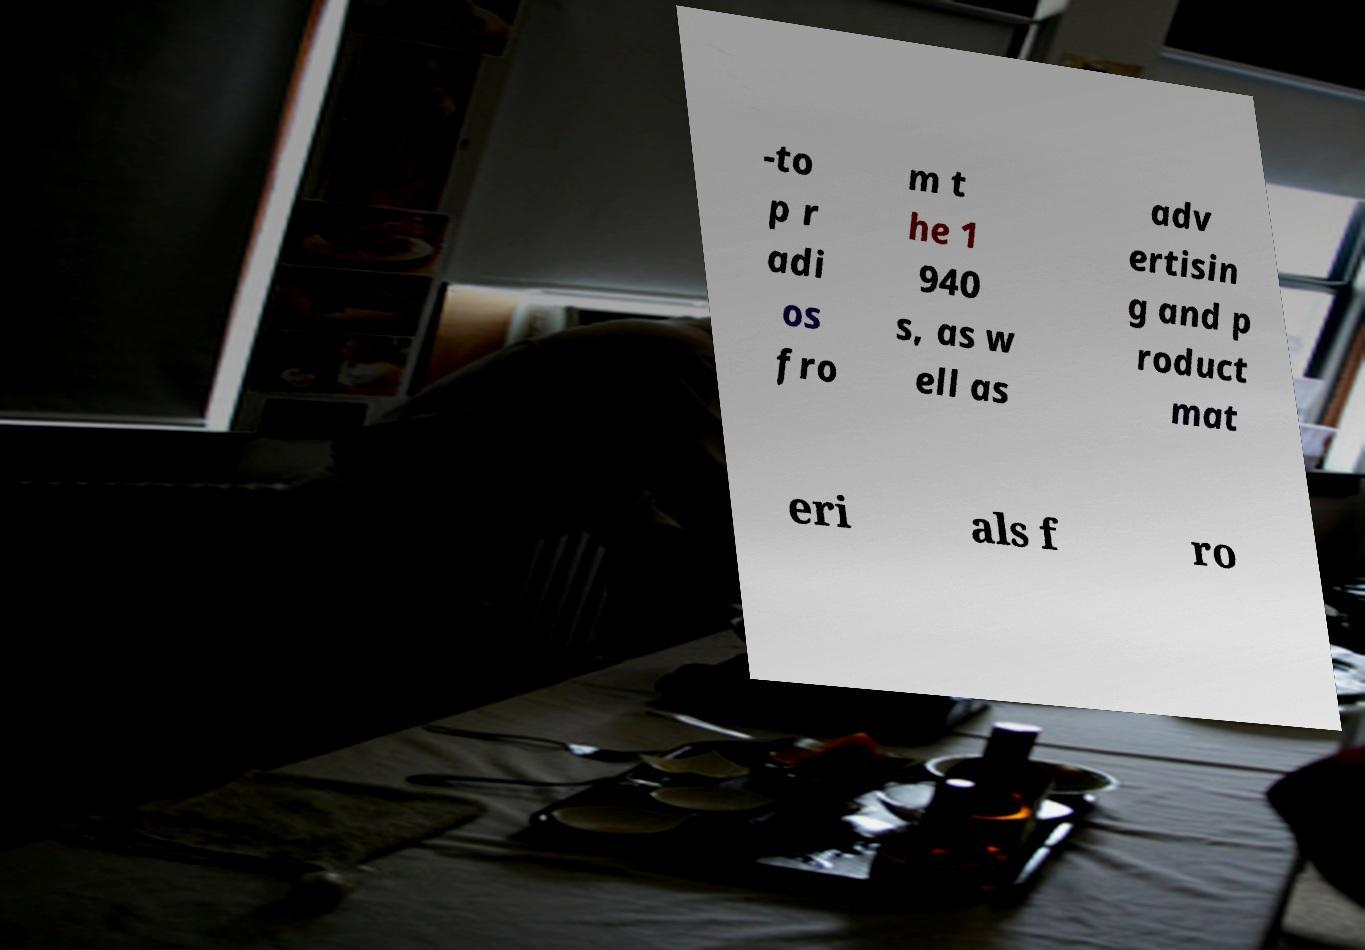Can you read and provide the text displayed in the image?This photo seems to have some interesting text. Can you extract and type it out for me? -to p r adi os fro m t he 1 940 s, as w ell as adv ertisin g and p roduct mat eri als f ro 